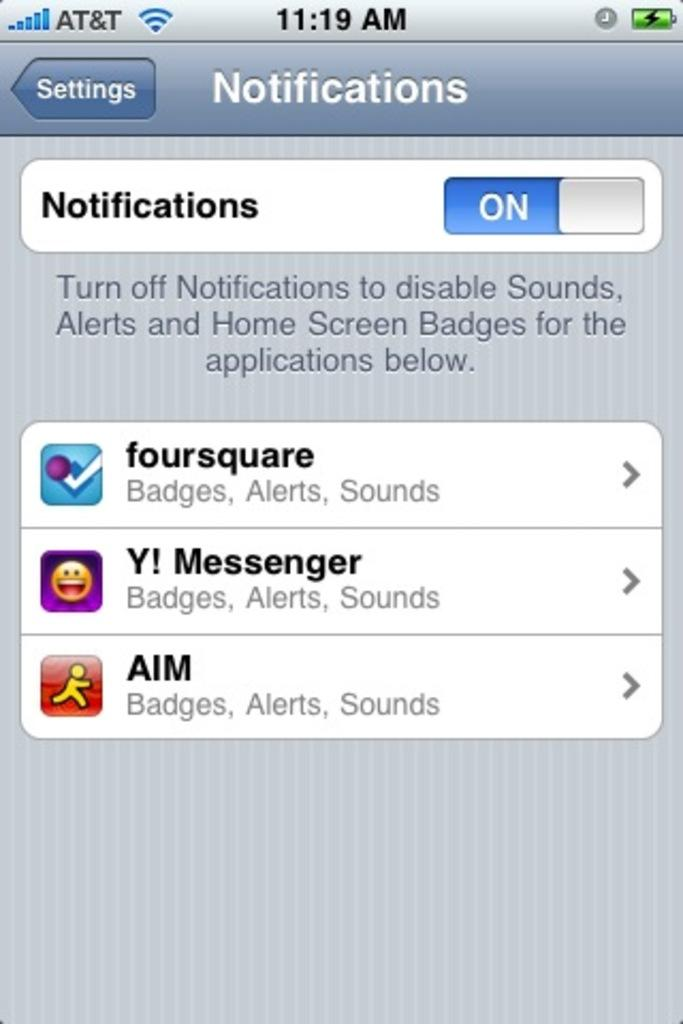<image>
Give a short and clear explanation of the subsequent image. An old screen shot of an iPhone screen showing notifications for AIM, and foursquare. 